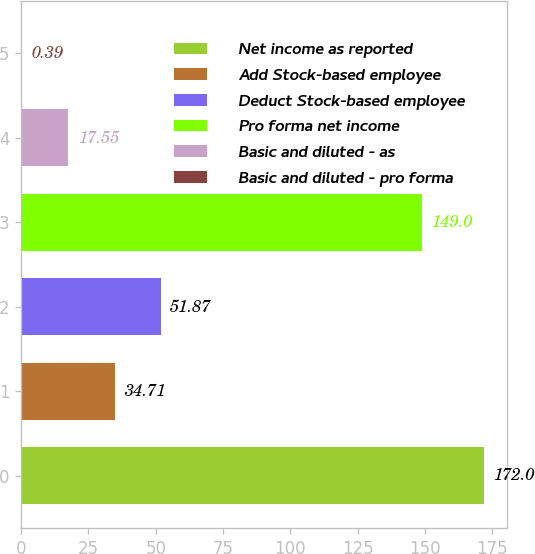Convert chart. <chart><loc_0><loc_0><loc_500><loc_500><bar_chart><fcel>Net income as reported<fcel>Add Stock-based employee<fcel>Deduct Stock-based employee<fcel>Pro forma net income<fcel>Basic and diluted - as<fcel>Basic and diluted - pro forma<nl><fcel>172<fcel>34.71<fcel>51.87<fcel>149<fcel>17.55<fcel>0.39<nl></chart> 